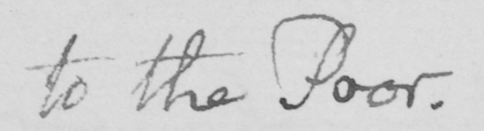Transcribe the text shown in this historical manuscript line. to the Poor . 